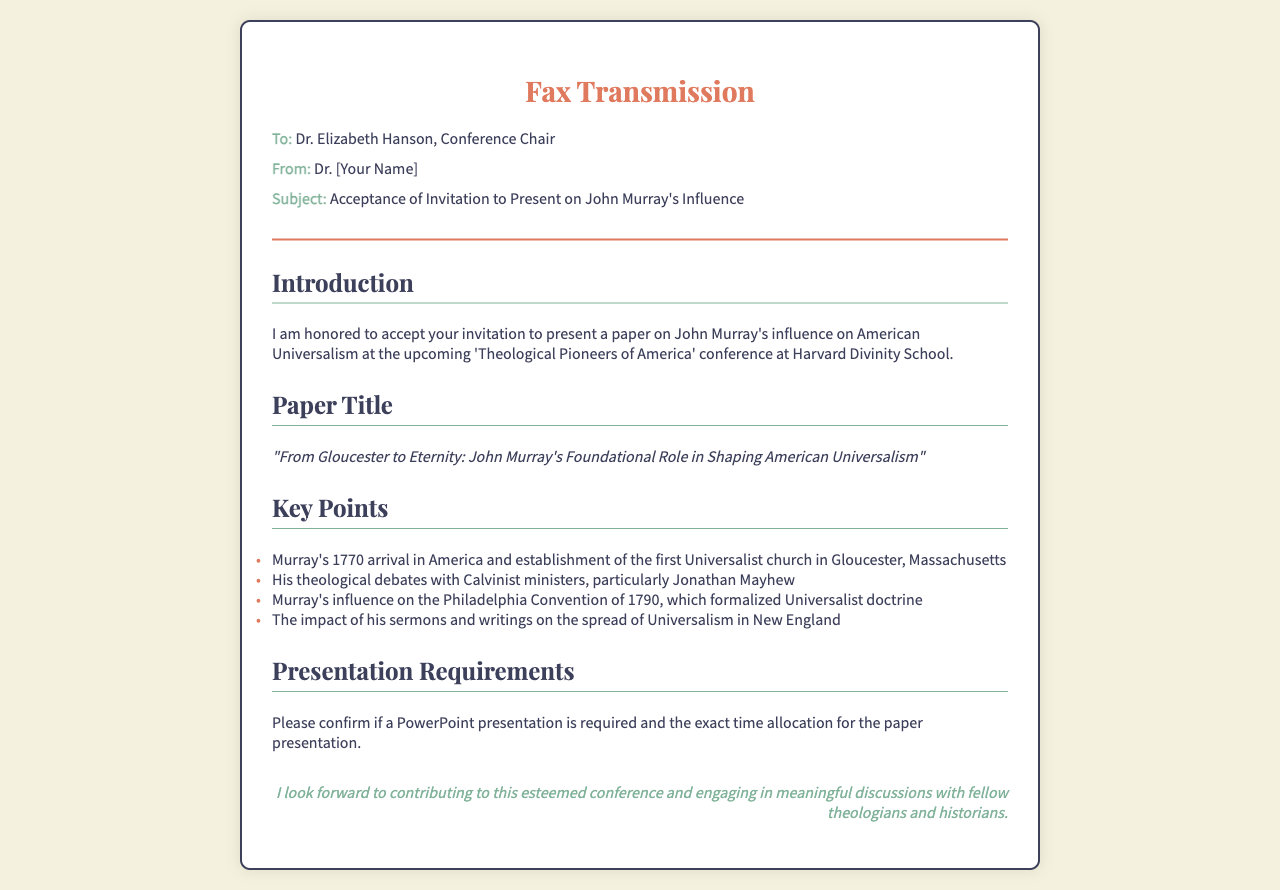What is the name of the conference? The name of the conference is mentioned in the document as 'Theological Pioneers of America'.
Answer: Theological Pioneers of America Who is the recipient of the fax? The fax specifies that it is addressed to Dr. Elizabeth Hanson, the Conference Chair.
Answer: Dr. Elizabeth Hanson What is the title of the paper being presented? The document states the paper title as, "From Gloucester to Eternity: John Murray's Foundational Role in Shaping American Universalism".
Answer: From Gloucester to Eternity: John Murray's Foundational Role in Shaping American Universalism What year did John Murray arrive in America? The document notes that John Murray arrived in America in 1770.
Answer: 1770 What key event is associated with the year 1790? The Philadelphia Convention of 1790 is mentioned as a key event where Universalist doctrine was formalized.
Answer: Philadelphia Convention of 1790 What elements does the author request confirmation on? The author asks for confirmation on whether a PowerPoint presentation is required and the exact time allocation for the presentation.
Answer: PowerPoint presentation and time allocation Who is the sender identified in the fax? The sender of the fax is identified as Dr. [Your Name].
Answer: Dr. [Your Name] What city is mentioned where the first Universalist church was established? Gloucester, Massachusetts is noted as the location of the first Universalist church established by Murray.
Answer: Gloucester, Massachusetts 